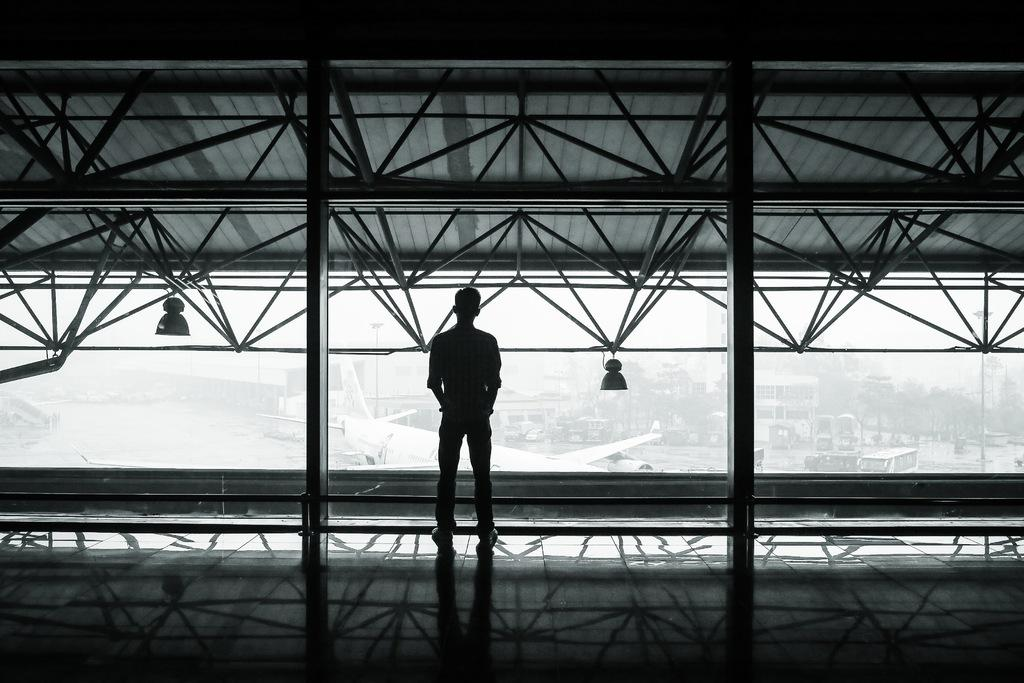What is the main subject of the image? There is a person in the image. Where is the person located in the image? The person is standing on the floor and under a roof. What can be seen in the background of the image? There are planes on a runway in the image. How is the image presented in terms of color? The image is in black and white. What type of headphones is the person wearing in the image? There is no mention of headphones in the image, so it cannot be determined if the person is wearing any. 